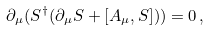Convert formula to latex. <formula><loc_0><loc_0><loc_500><loc_500>\partial _ { \mu } ( S ^ { \dagger } ( \partial _ { \mu } S + [ A _ { \mu } , S ] ) ) = 0 \, ,</formula> 